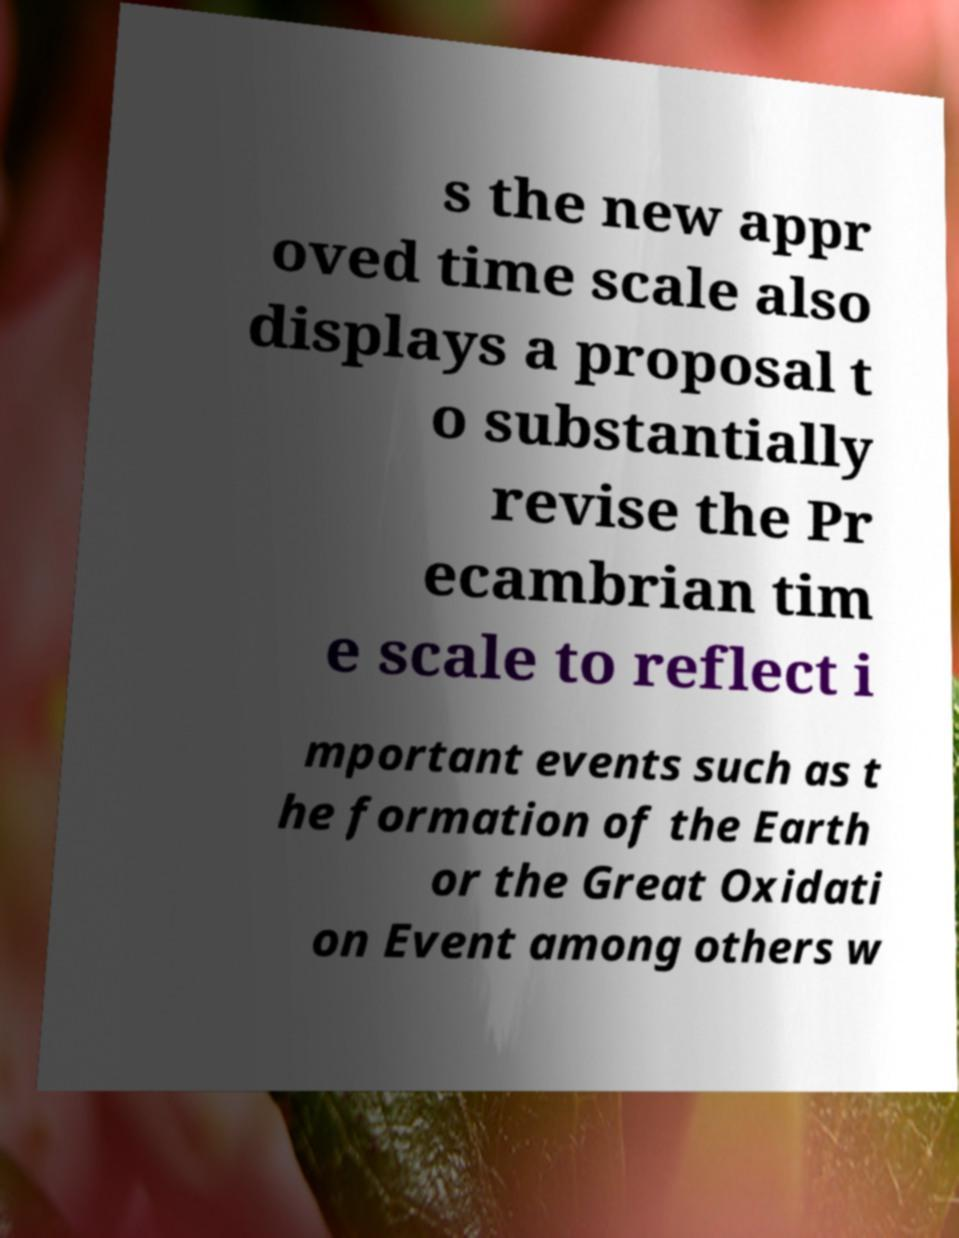Could you assist in decoding the text presented in this image and type it out clearly? s the new appr oved time scale also displays a proposal t o substantially revise the Pr ecambrian tim e scale to reflect i mportant events such as t he formation of the Earth or the Great Oxidati on Event among others w 